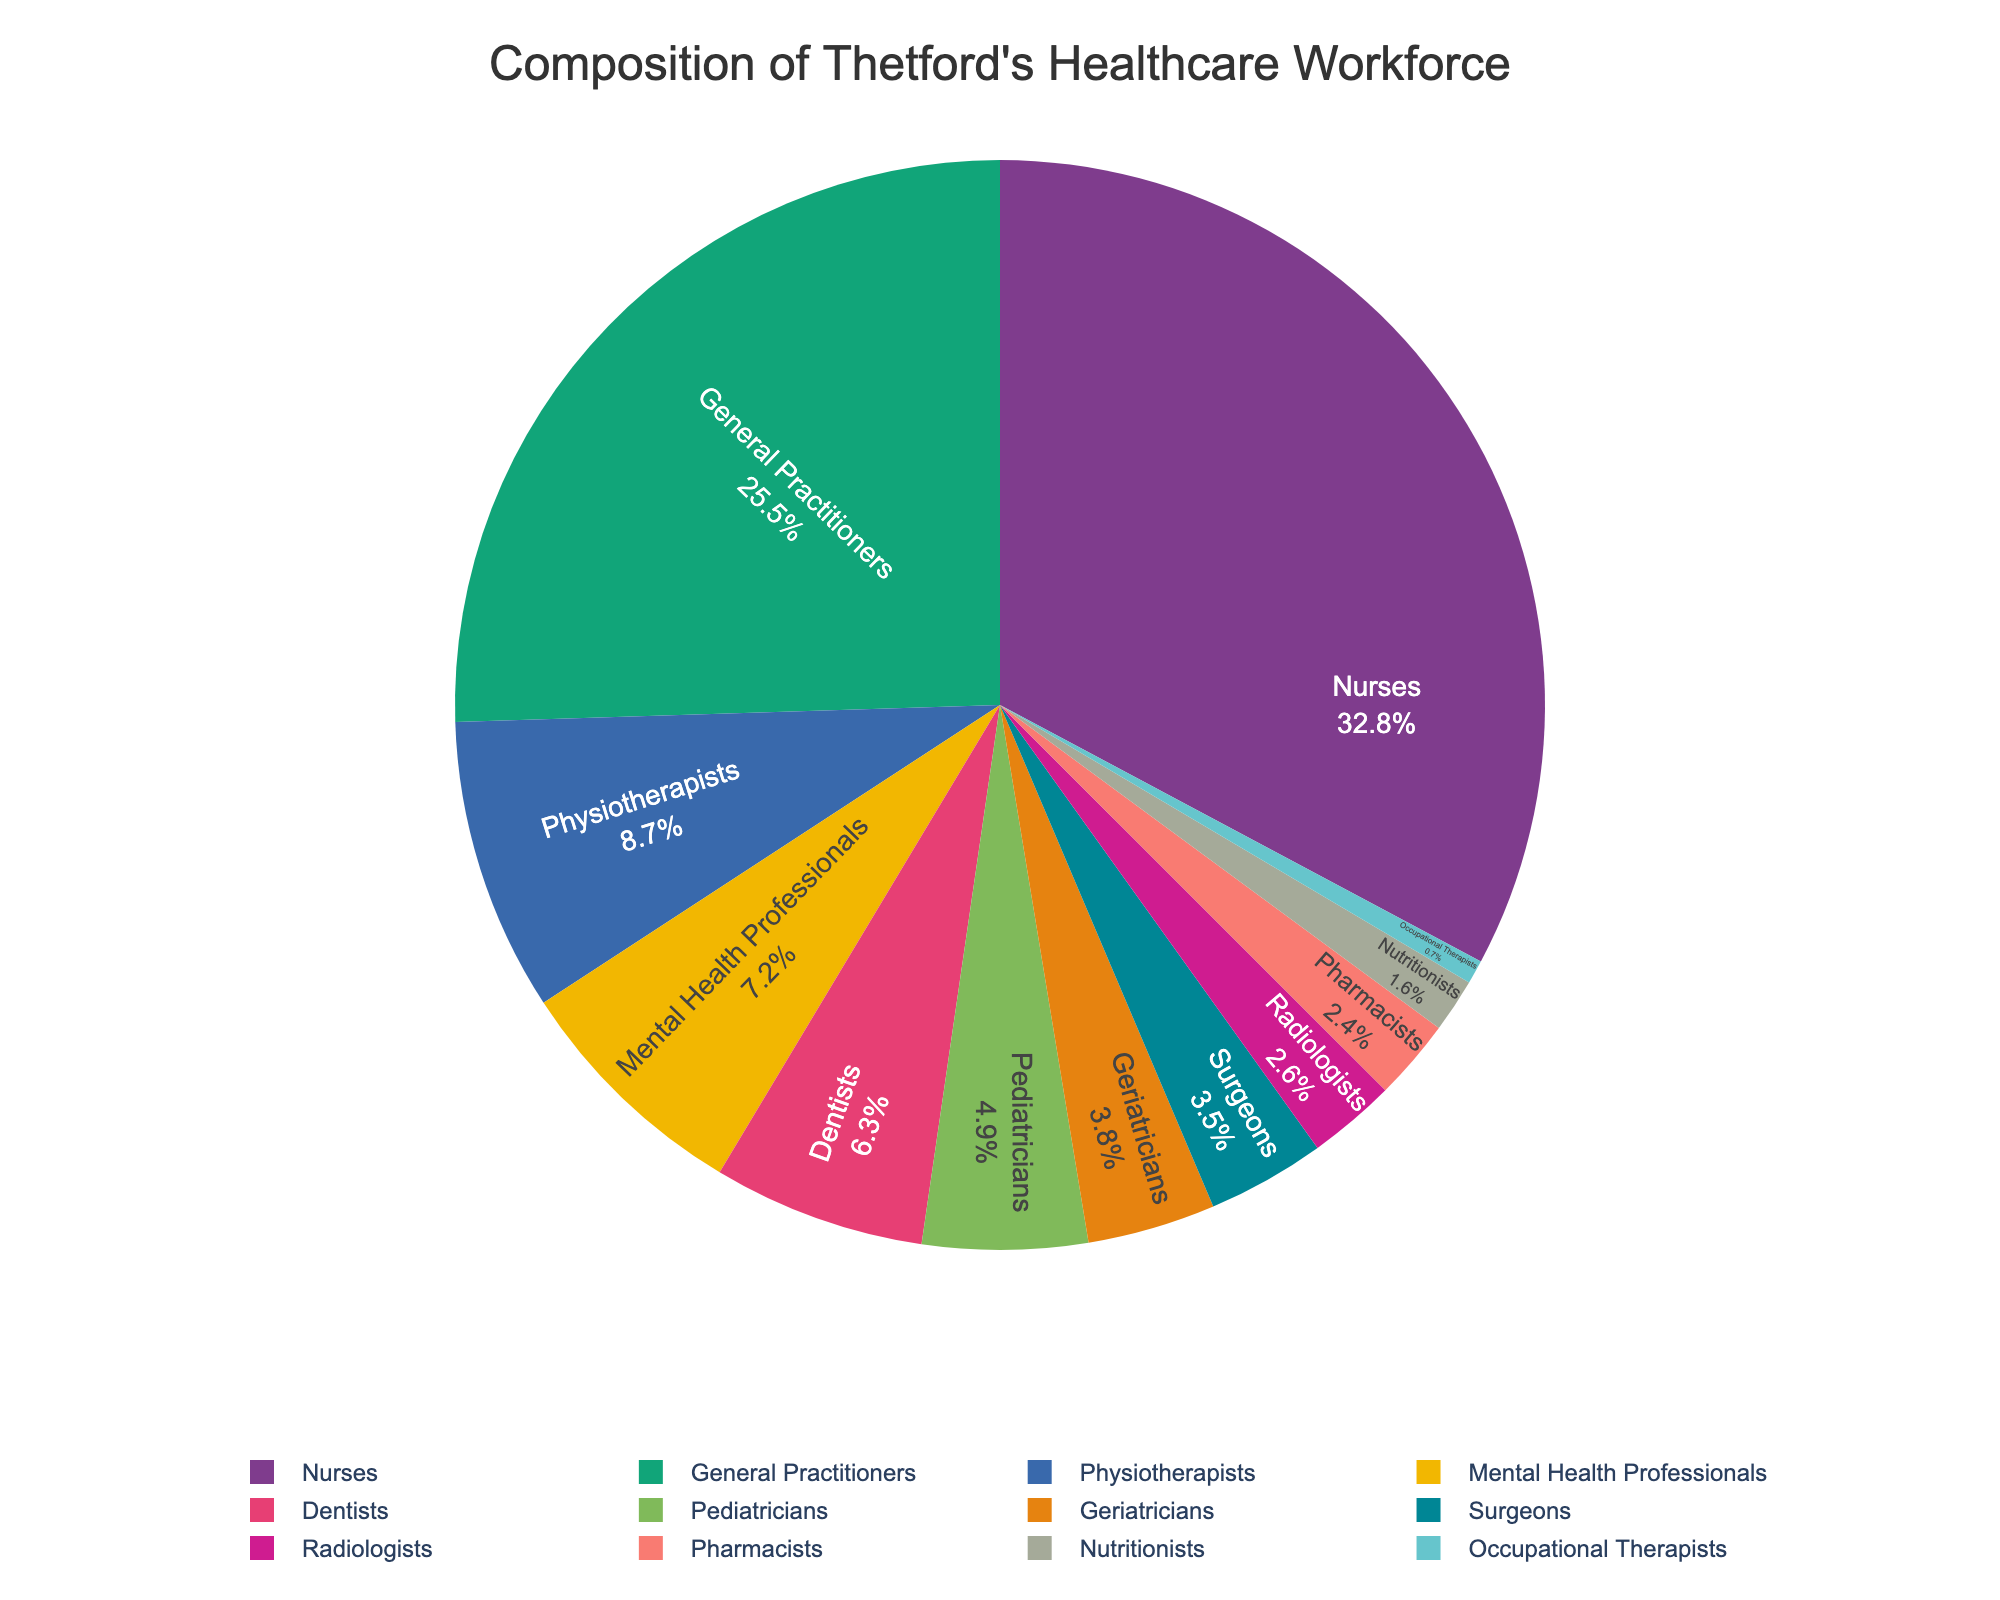Which specialization has the highest percentage in Thetford's healthcare workforce? The pie chart shows each specialization as a portion of the whole. The largest portion corresponds to the specialization with the highest percentage. In this chart, Nurses constitute the largest part.
Answer: Nurses How much larger is the percentage of General Practitioners compared to Surgeons? Identify the percentages of General Practitioners (25.5%) and Surgeons (3.5%) from the chart. Subtract the percentage of Surgeons from that of the General Practitioners: 25.5% - 3.5% = 22.0%.
Answer: 22.0% What is the combined percentage of Pediatricians and Geriatricians? Find the percentages of Pediatricians (4.9%) and Geriatricians (3.8%) in the chart, then sum them: 4.9% + 3.8% = 8.7%.
Answer: 8.7% Which specialization has a slightly smaller percentage than Mental Health Professionals but slightly larger than Pharmacists? From the chart, we see that Mental Health Professionals are 7.2% and Pharmacists are 2.4%. The specialization between these two is Radiologists at 2.6%.
Answer: Radiologists What is the proportion of Nurses to General Practitioners? The pie chart shows Nurses at 32.8% and General Practitioners at 25.5%. The proportion is the ratio 32.8% to 25.5%, which simplifies to approximately 1.29 when dividing 32.8 by 25.5.
Answer: 1.29 Is the total percentage contribution of Dentists and Nutritionists smaller than that of Physiotherapists? The chart shows Dentists at 6.3% and Nutritionists at 1.6%. Adding them together gives 6.3% + 1.6% = 7.9%. Physiotherapists make up 8.7%. Comparing the two sums, 7.9% is indeed smaller than 8.7%.
Answer: Yes Which specialization has the least representation in Thetford's healthcare workforce? By identifying the smallest segment in the pie chart, we can see that Occupational Therapists have the smallest percentage at 0.7%.
Answer: Occupational Therapists What is the difference in percentage points between Nurses and Mental Health Professionals? Nurses are shown at 32.8% and Mental Health Professionals at 7.2%. Subtract the percentage of Mental Health Professionals from Nurses: 32.8% - 7.2% = 25.6%.
Answer: 25.6% If the total workforce is 10,000, how many people specialize in General Practice? The percentage of General Practitioners is 25.5%. Calculate the number by taking 25.5% of 10,000: 0.255 * 10,000 = 2,550.
Answer: 2,550 